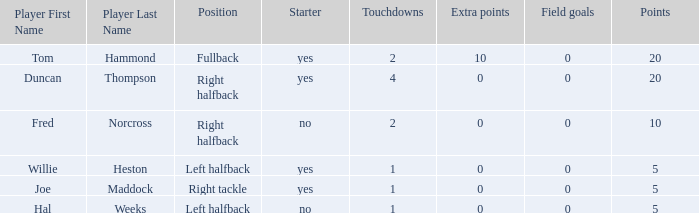What is the lowest number of field goals when the points were less than 5? None. 